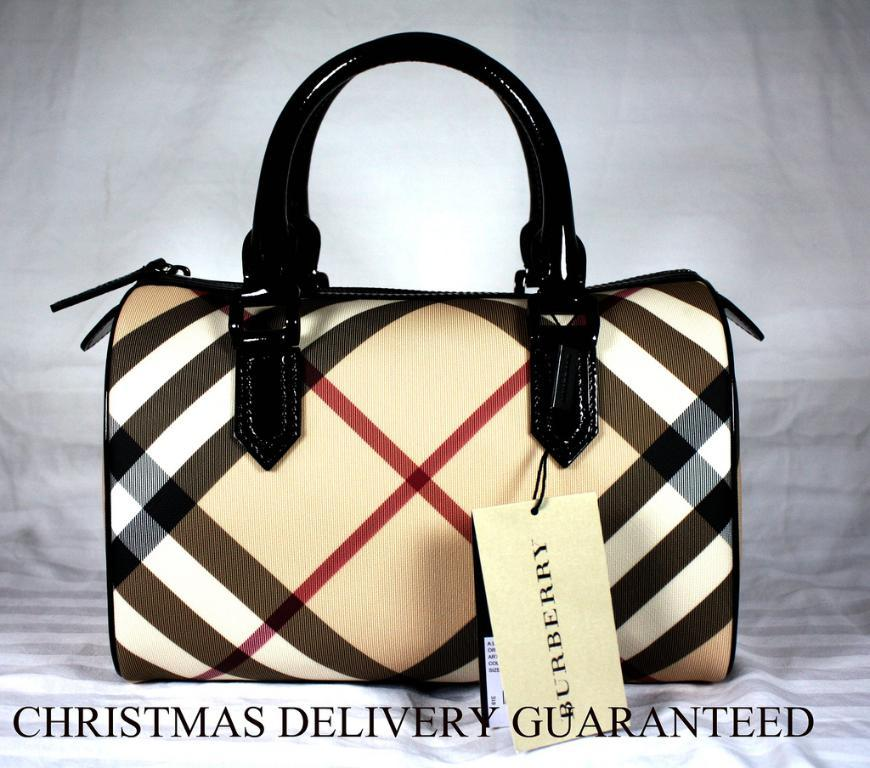What is the main object visible in the image? There is a handbag in the image. How many dimes are inside the handbag in the image? There is no information about the contents of the handbag, including the presence of dimes, in the provided facts. 